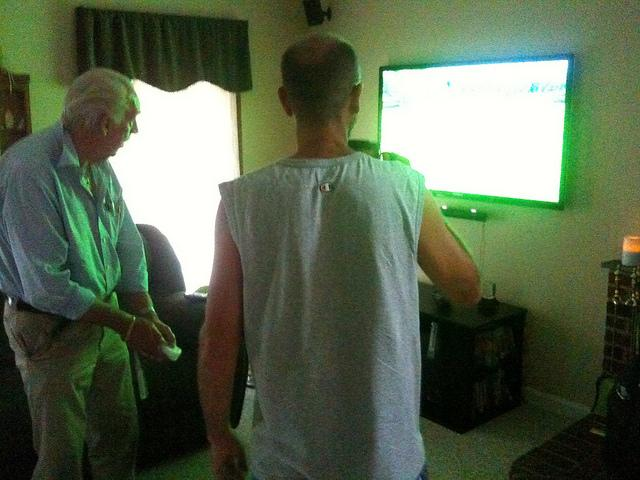Which sport is the man on the left most likely playing on the nintendo wii appliance?

Choices:
A) tennis
B) baseball
C) golf
D) boxing golf 